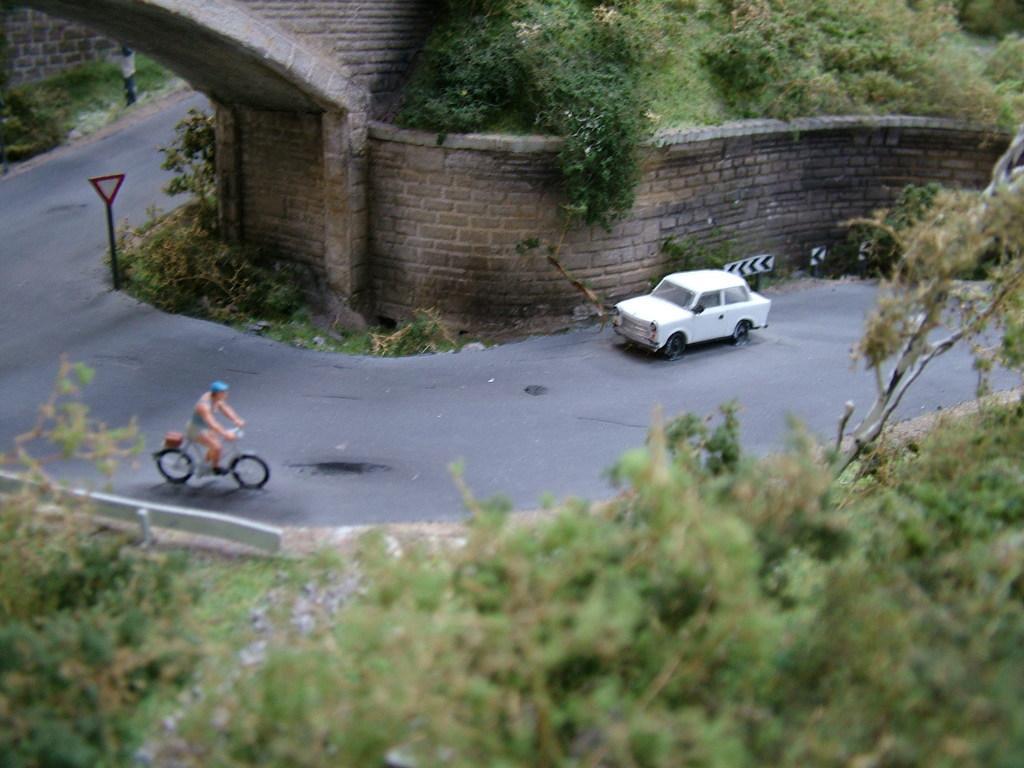Could you give a brief overview of what you see in this image? Car is on the road. A person is riding a bicycle. Here we can see a signboard, trees and plants. 